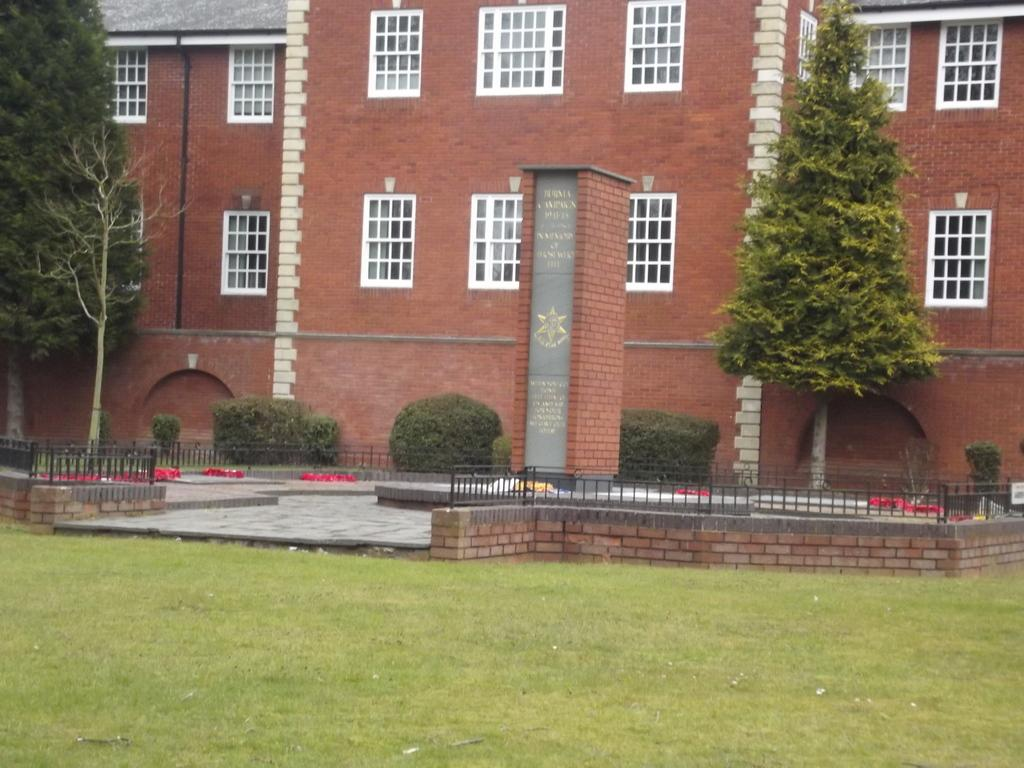What type of structures can be seen in the image? There are buildings in the image. What architectural feature is present in the buildings? There are windows in the image. What type of vegetation is present in the image? There are plants and trees in the image. What type of barrier can be seen in the image? There is a fence in the image. What type of ground cover is present in the image? There is grass in the image. How many potatoes are visible in the image? There are no potatoes present in the image. What type of currency can be seen in the image? There is no currency visible in the image. 